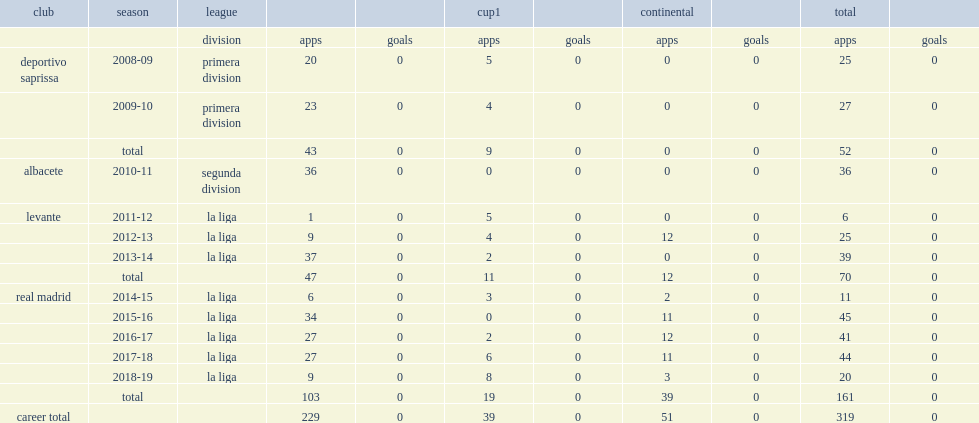Which club did navas play for, in the 2015-16 la liga season? Real madrid. 